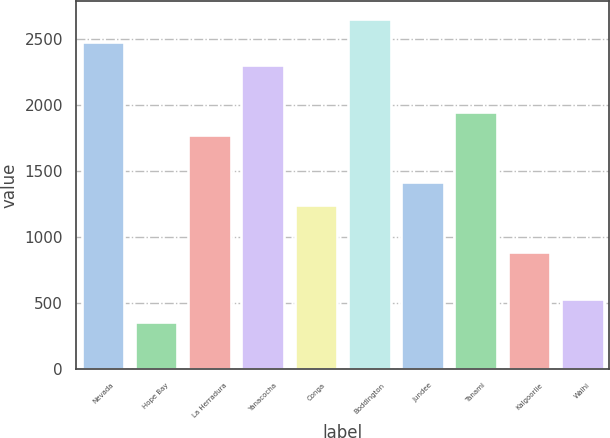<chart> <loc_0><loc_0><loc_500><loc_500><bar_chart><fcel>Nevada<fcel>Hope Bay<fcel>La Herradura<fcel>Yanacocha<fcel>Conga<fcel>Boddington<fcel>Jundee<fcel>Tanami<fcel>Kalgoorlie<fcel>Waihi<nl><fcel>2481<fcel>357<fcel>1773<fcel>2304<fcel>1242<fcel>2658<fcel>1419<fcel>1950<fcel>888<fcel>534<nl></chart> 